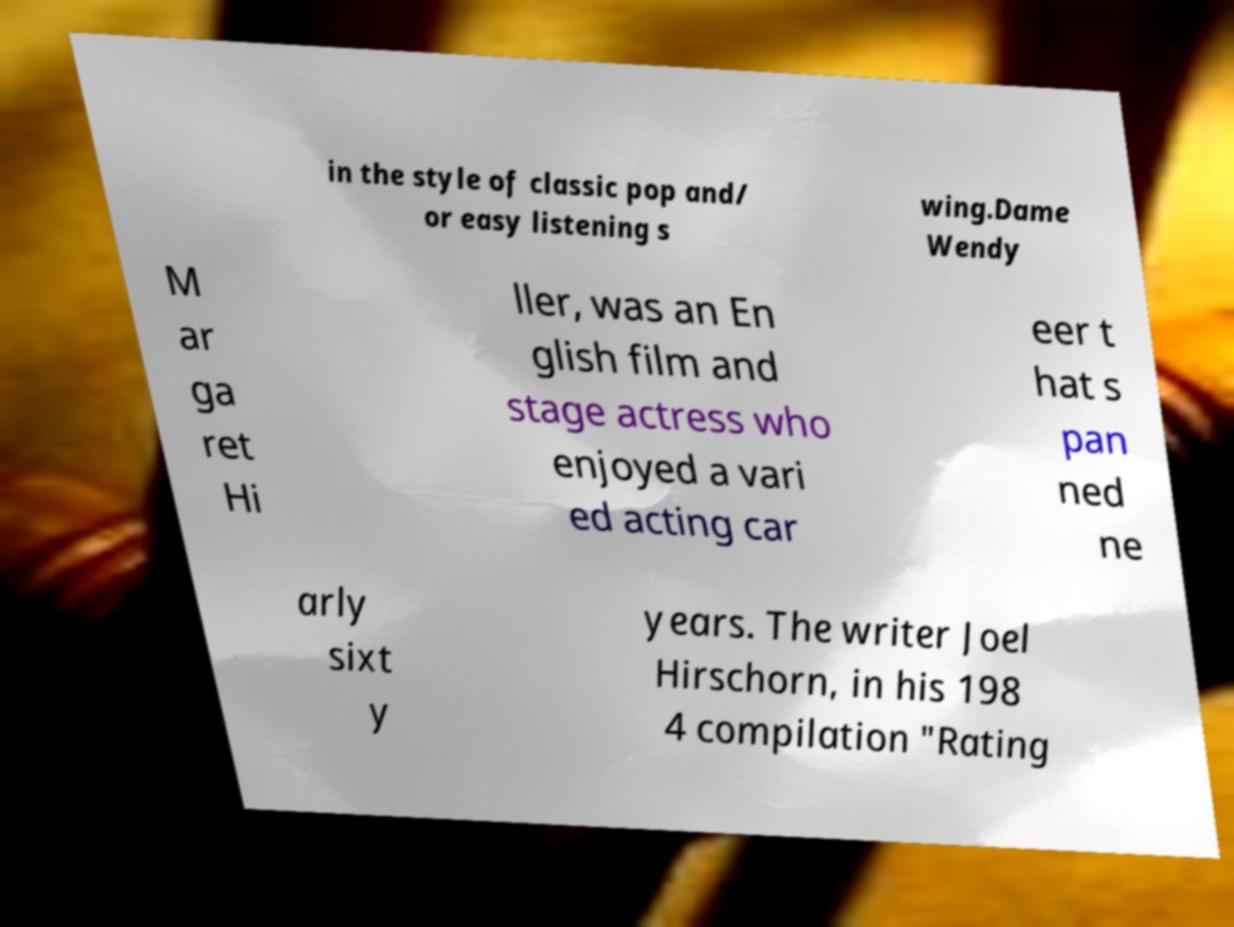Can you accurately transcribe the text from the provided image for me? in the style of classic pop and/ or easy listening s wing.Dame Wendy M ar ga ret Hi ller, was an En glish film and stage actress who enjoyed a vari ed acting car eer t hat s pan ned ne arly sixt y years. The writer Joel Hirschorn, in his 198 4 compilation "Rating 